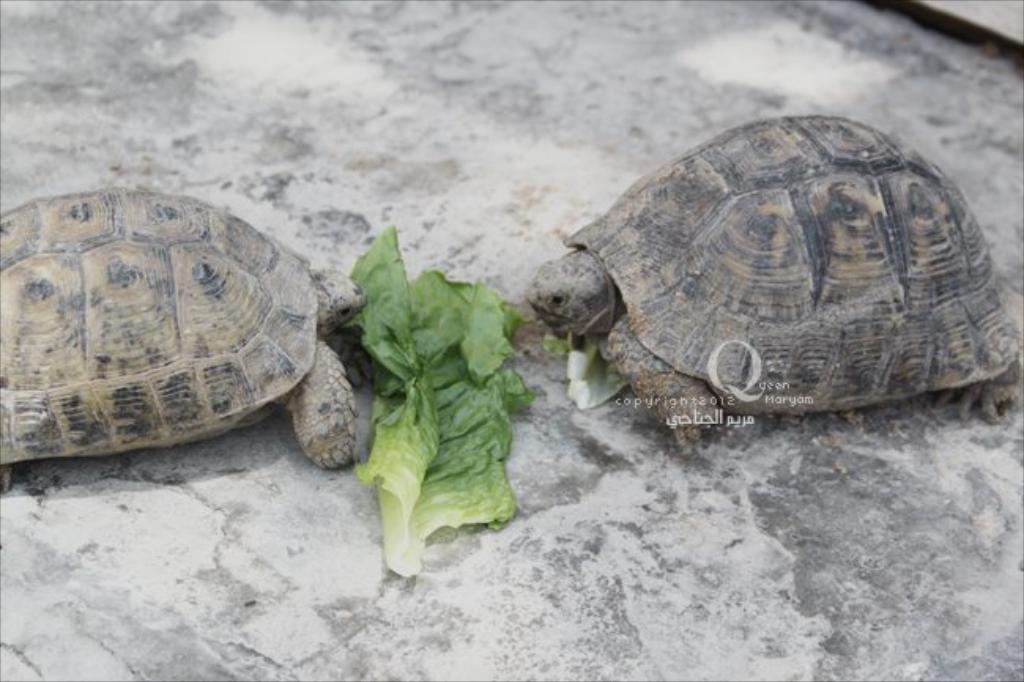Could you give a brief overview of what you see in this image? In this image we can see tortoises on a surface. In between the tortoises we can see the leaves. 